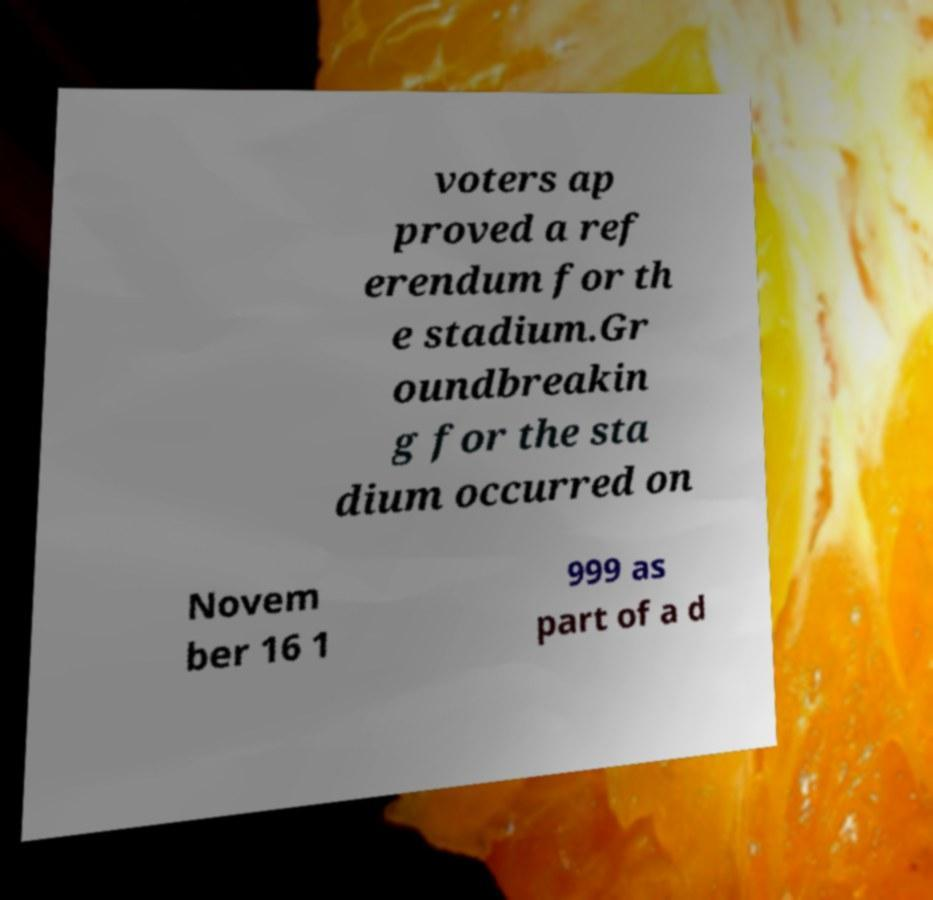Can you accurately transcribe the text from the provided image for me? voters ap proved a ref erendum for th e stadium.Gr oundbreakin g for the sta dium occurred on Novem ber 16 1 999 as part of a d 